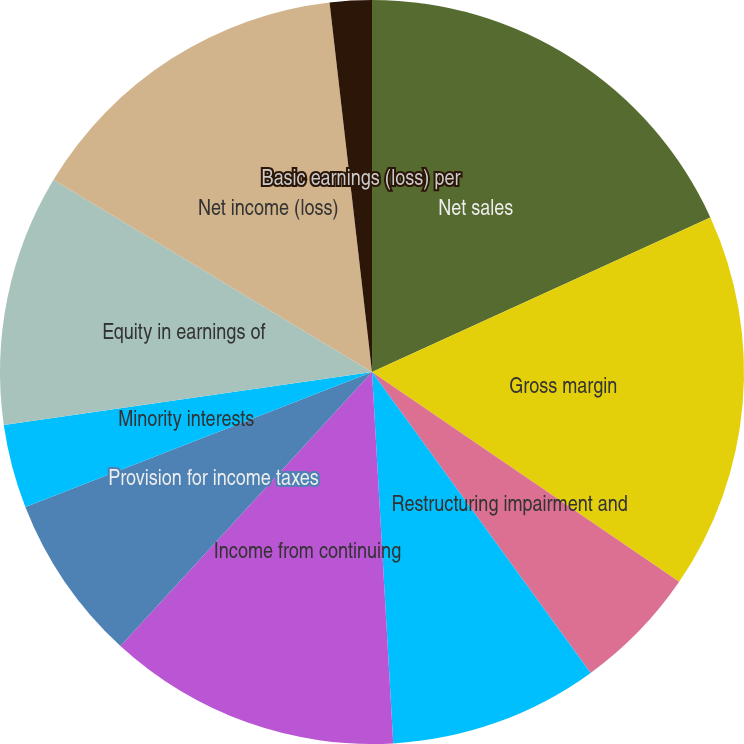Convert chart to OTSL. <chart><loc_0><loc_0><loc_500><loc_500><pie_chart><fcel>Net sales<fcel>Gross margin<fcel>Restructuring impairment and<fcel>Asbestos settlement (credits)<fcel>Income from continuing<fcel>Provision for income taxes<fcel>Minority interests<fcel>Equity in earnings of<fcel>Net income (loss)<fcel>Basic earnings (loss) per<nl><fcel>18.18%<fcel>16.36%<fcel>5.46%<fcel>9.09%<fcel>12.73%<fcel>7.27%<fcel>3.64%<fcel>10.91%<fcel>14.54%<fcel>1.82%<nl></chart> 